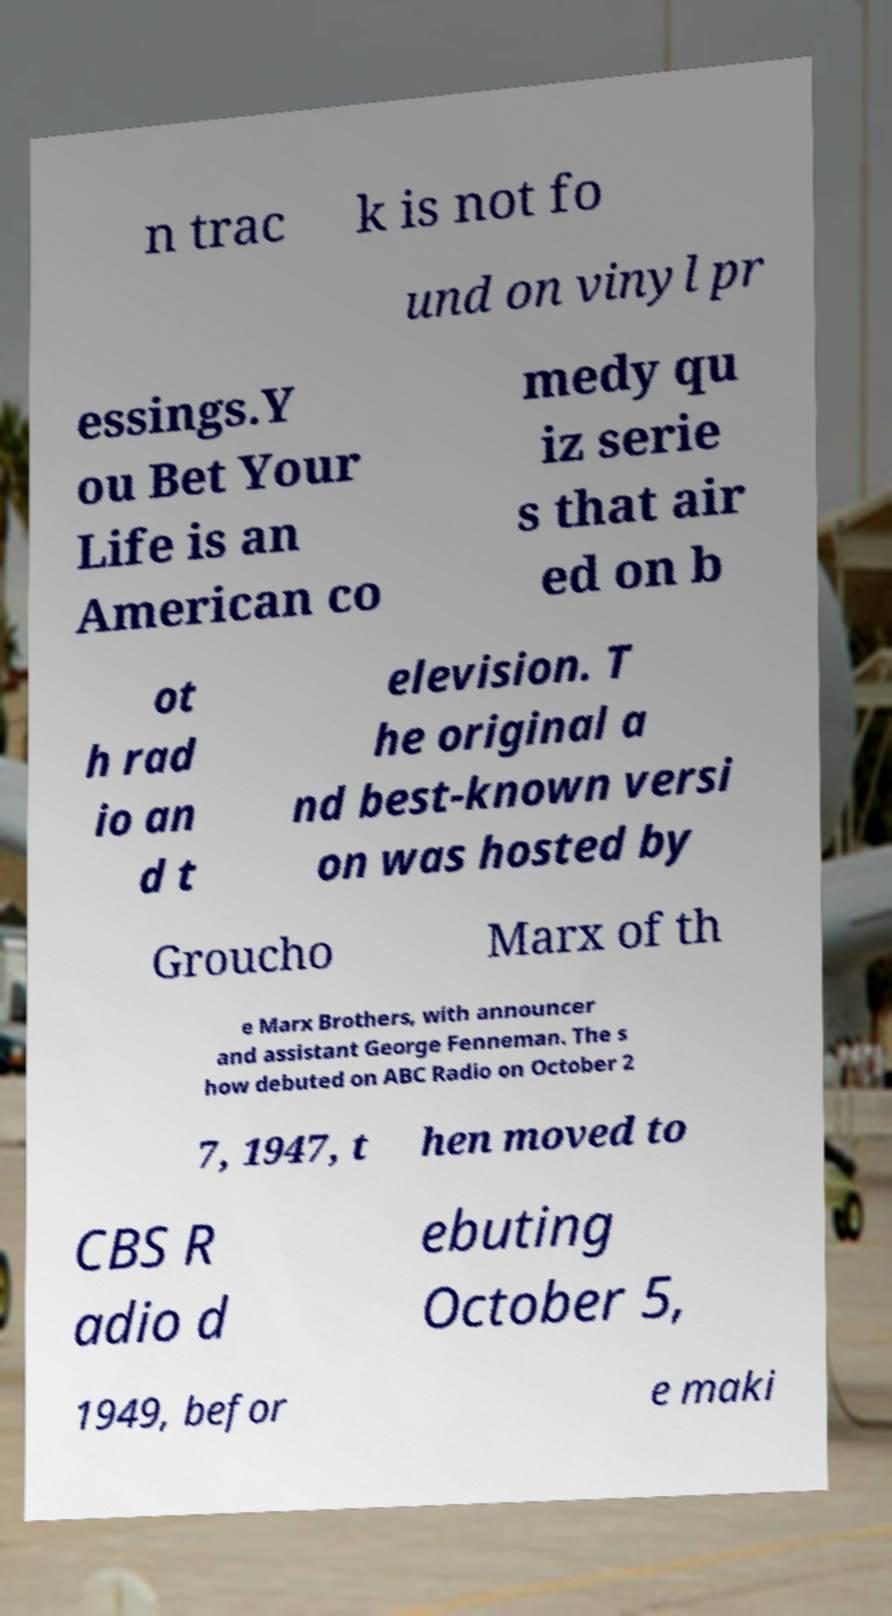What messages or text are displayed in this image? I need them in a readable, typed format. n trac k is not fo und on vinyl pr essings.Y ou Bet Your Life is an American co medy qu iz serie s that air ed on b ot h rad io an d t elevision. T he original a nd best-known versi on was hosted by Groucho Marx of th e Marx Brothers, with announcer and assistant George Fenneman. The s how debuted on ABC Radio on October 2 7, 1947, t hen moved to CBS R adio d ebuting October 5, 1949, befor e maki 